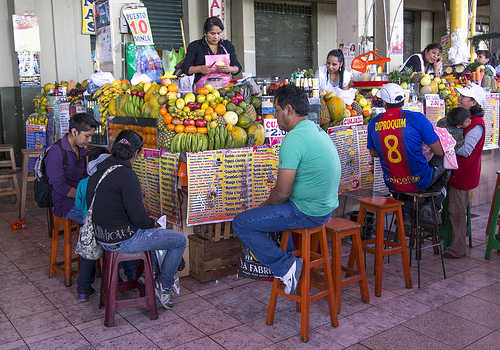<image>
Can you confirm if the person is on the stool? No. The person is not positioned on the stool. They may be near each other, but the person is not supported by or resting on top of the stool. 